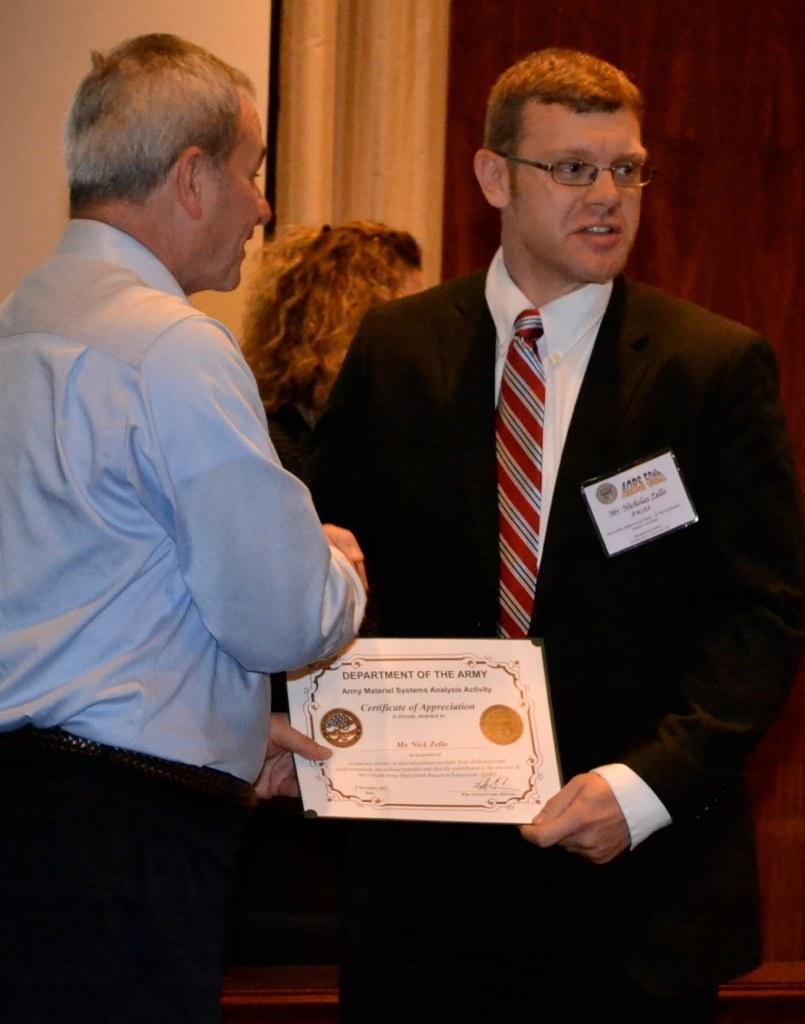How many people are in the image? There are two persons in the image. What are the two persons holding? The two persons are holding a certificate. Can you describe anything in the background of the image? There is a woman visible in the background of the image. What type of calculator is being used by the woman in the image? There is no calculator visible in the image; only the two persons holding a certificate and a woman in the background are present. 